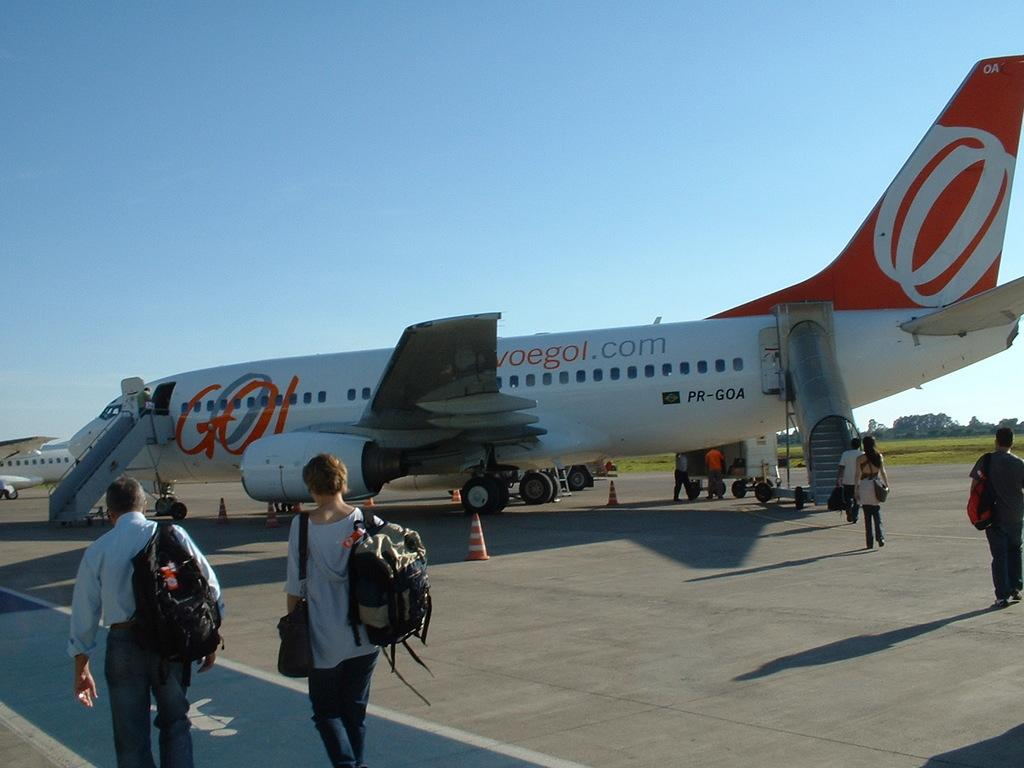<image>
Write a terse but informative summary of the picture. People walk toward a plane with a stylized GO on the side. 